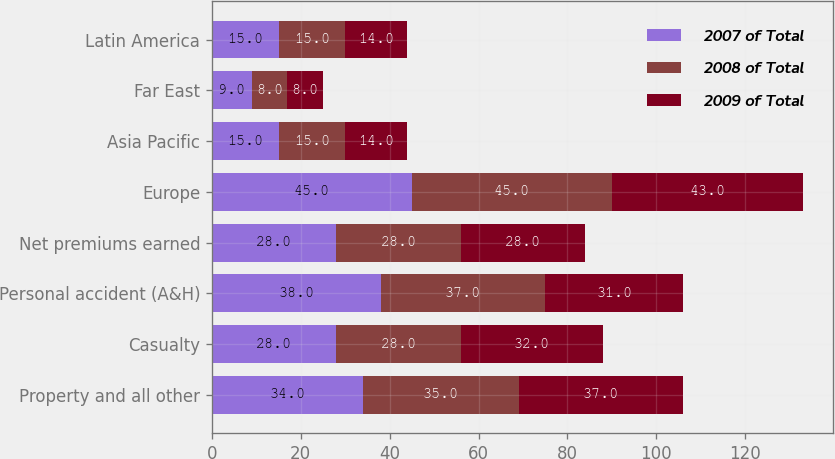<chart> <loc_0><loc_0><loc_500><loc_500><stacked_bar_chart><ecel><fcel>Property and all other<fcel>Casualty<fcel>Personal accident (A&H)<fcel>Net premiums earned<fcel>Europe<fcel>Asia Pacific<fcel>Far East<fcel>Latin America<nl><fcel>2007 of Total<fcel>34<fcel>28<fcel>38<fcel>28<fcel>45<fcel>15<fcel>9<fcel>15<nl><fcel>2008 of Total<fcel>35<fcel>28<fcel>37<fcel>28<fcel>45<fcel>15<fcel>8<fcel>15<nl><fcel>2009 of Total<fcel>37<fcel>32<fcel>31<fcel>28<fcel>43<fcel>14<fcel>8<fcel>14<nl></chart> 